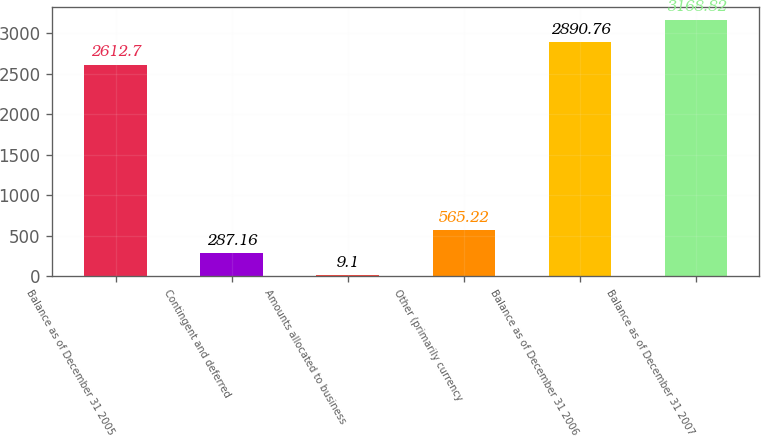<chart> <loc_0><loc_0><loc_500><loc_500><bar_chart><fcel>Balance as of December 31 2005<fcel>Contingent and deferred<fcel>Amounts allocated to business<fcel>Other (primarily currency<fcel>Balance as of December 31 2006<fcel>Balance as of December 31 2007<nl><fcel>2612.7<fcel>287.16<fcel>9.1<fcel>565.22<fcel>2890.76<fcel>3168.82<nl></chart> 